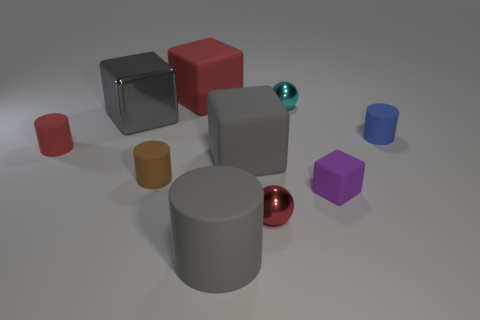Are there any brown rubber objects of the same shape as the blue object?
Your answer should be compact. Yes. What shape is the red object right of the big rubber cube that is behind the red matte cylinder?
Ensure brevity in your answer.  Sphere. There is a small metal thing in front of the tiny brown cylinder; what is its shape?
Keep it short and to the point. Sphere. There is a big object that is behind the cyan object; is its color the same as the small shiny object that is on the right side of the tiny red metallic thing?
Provide a short and direct response. No. What number of cylinders are both right of the small red rubber cylinder and behind the small cube?
Offer a very short reply. 2. The red cylinder that is the same material as the purple object is what size?
Your answer should be compact. Small. The purple rubber block is what size?
Offer a very short reply. Small. What is the big cylinder made of?
Provide a succinct answer. Rubber. Does the gray matte object in front of the red shiny sphere have the same size as the small brown matte cylinder?
Offer a terse response. No. What number of objects are large matte cylinders or red objects?
Make the answer very short. 4. 